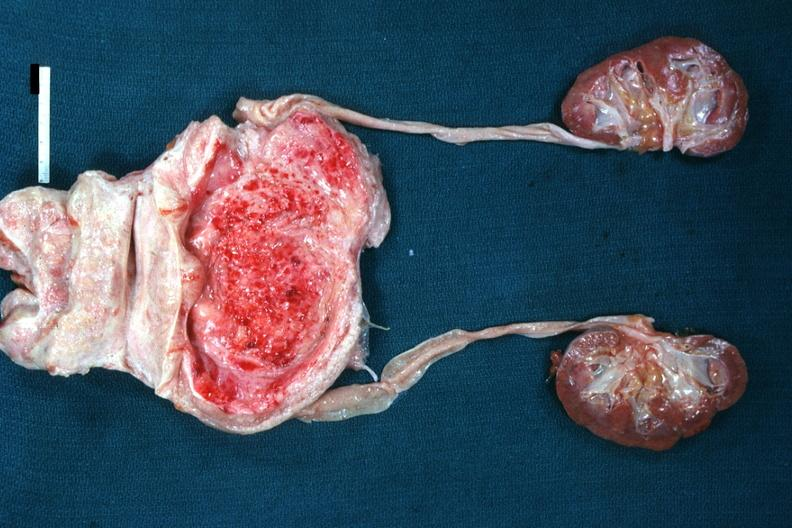s hyperplasia present?
Answer the question using a single word or phrase. Yes 